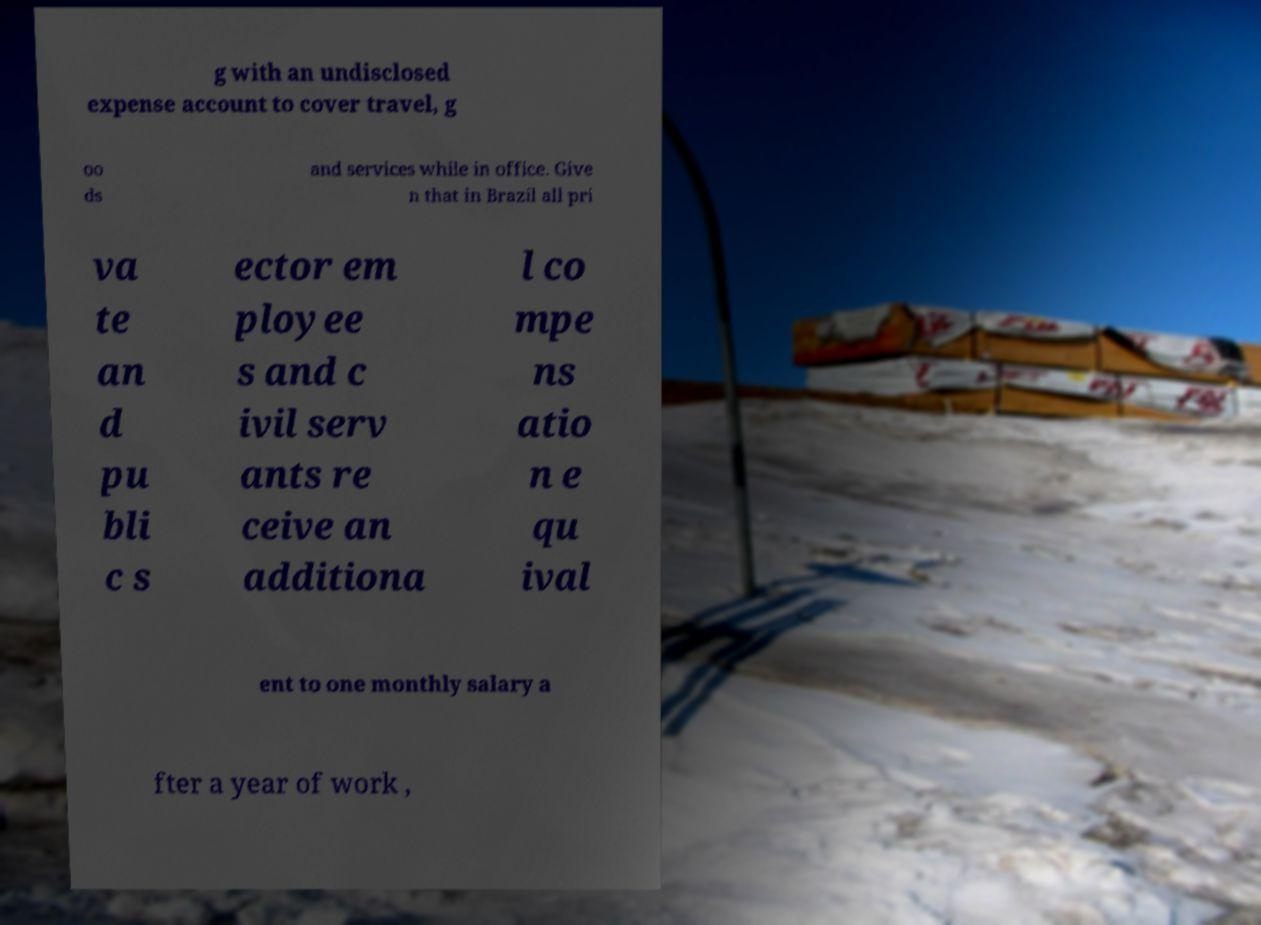Could you extract and type out the text from this image? g with an undisclosed expense account to cover travel, g oo ds and services while in office. Give n that in Brazil all pri va te an d pu bli c s ector em ployee s and c ivil serv ants re ceive an additiona l co mpe ns atio n e qu ival ent to one monthly salary a fter a year of work , 